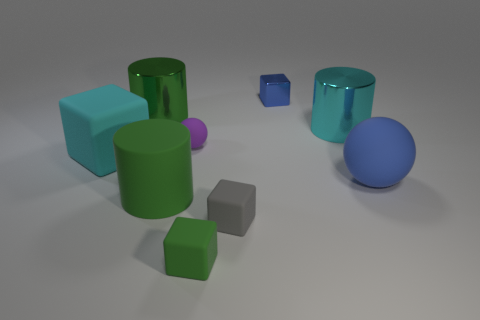There is a green object that is the same size as the blue cube; what material is it?
Provide a short and direct response. Rubber. The big thing behind the large metallic cylinder that is right of the green metal cylinder is what color?
Keep it short and to the point. Green. How many shiny cylinders are right of the small gray rubber block?
Offer a terse response. 1. The small shiny object has what color?
Provide a succinct answer. Blue. How many small objects are either green metal objects or cyan matte cubes?
Your answer should be compact. 0. Does the cube that is to the left of the tiny purple thing have the same color as the cube to the right of the gray object?
Your response must be concise. No. What number of other objects are the same color as the small ball?
Your answer should be very brief. 0. The blue thing that is on the right side of the cyan metallic cylinder has what shape?
Provide a short and direct response. Sphere. Is the number of small purple rubber spheres less than the number of small red rubber things?
Your answer should be compact. No. Are the large green cylinder that is in front of the large green metal cylinder and the small blue block made of the same material?
Provide a short and direct response. No. 